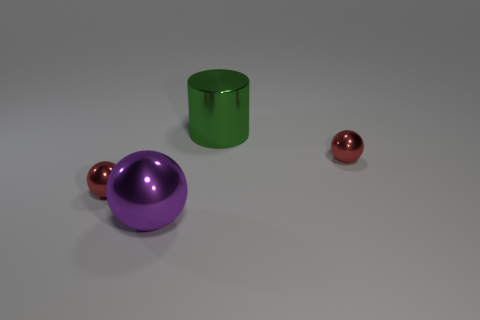How many big green cylinders are made of the same material as the large green object?
Offer a terse response. 0. What size is the purple thing in front of the cylinder?
Offer a terse response. Large. There is a large metallic object in front of the sphere on the right side of the green metal cylinder; what is its shape?
Ensure brevity in your answer.  Sphere. There is a tiny red metal object left of the green metal cylinder behind the large purple thing; how many purple balls are in front of it?
Offer a very short reply. 1. Are there fewer objects in front of the purple shiny object than large metallic cylinders?
Keep it short and to the point. Yes. Is there any other thing that has the same shape as the purple metal object?
Ensure brevity in your answer.  Yes. The big purple object to the left of the large green object has what shape?
Make the answer very short. Sphere. The large metal object behind the tiny object in front of the tiny red thing on the right side of the cylinder is what shape?
Provide a short and direct response. Cylinder. What number of objects are either large spheres or tiny purple things?
Offer a terse response. 1. There is a red thing to the left of the shiny cylinder; is its shape the same as the tiny metallic object that is on the right side of the large cylinder?
Your answer should be compact. Yes. 